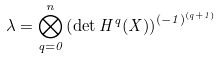<formula> <loc_0><loc_0><loc_500><loc_500>\lambda = \bigotimes _ { q = 0 } ^ { n } \left ( \det H ^ { q } ( X ) \right ) ^ { ( - 1 ) ^ { ( q + 1 ) } }</formula> 